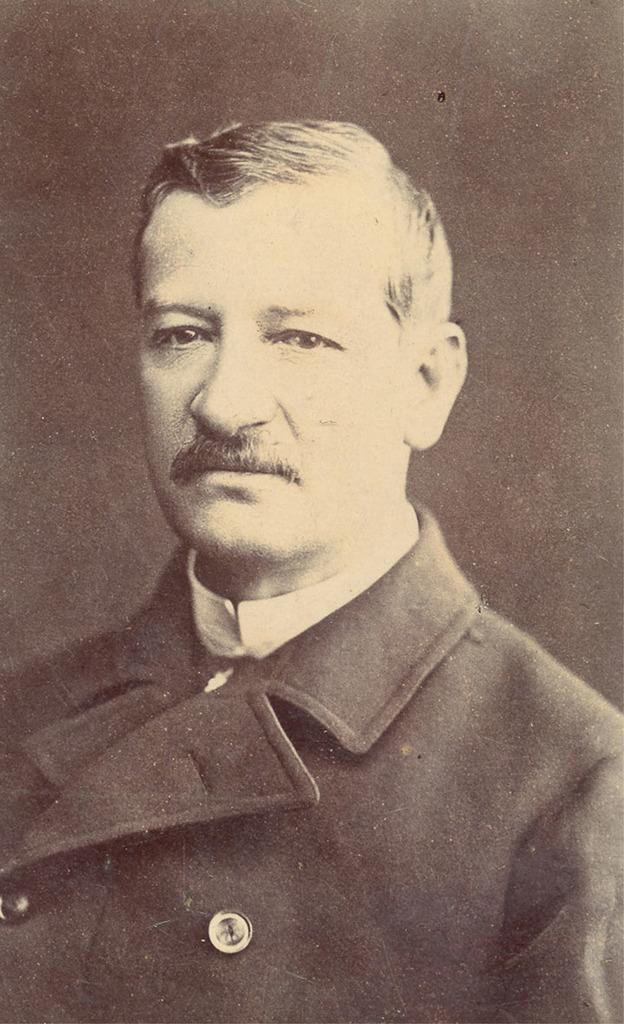Please provide a concise description of this image. This picture is a black and white image. In this image we can see one man in a suit, there is a black background and the background is blurred. 